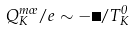<formula> <loc_0><loc_0><loc_500><loc_500>Q _ { K } ^ { m \sigma } / e \sim - \Delta / T _ { K } ^ { 0 }</formula> 